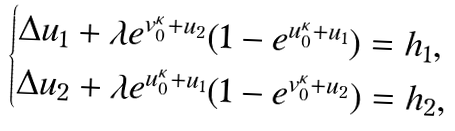Convert formula to latex. <formula><loc_0><loc_0><loc_500><loc_500>\begin{cases} \Delta u _ { 1 } + \lambda e ^ { v _ { 0 } ^ { \kappa } + u _ { 2 } } ( 1 - e ^ { u _ { 0 } ^ { \kappa } + u _ { 1 } } ) = h _ { 1 } , \\ \Delta u _ { 2 } + \lambda e ^ { u _ { 0 } ^ { \kappa } + u _ { 1 } } ( 1 - e ^ { v _ { 0 } ^ { \kappa } + u _ { 2 } } ) = h _ { 2 } , \end{cases}</formula> 